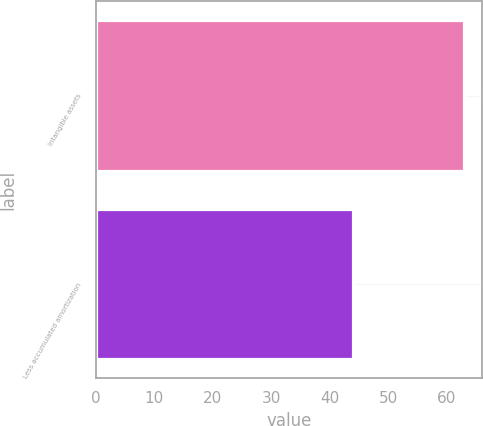<chart> <loc_0><loc_0><loc_500><loc_500><bar_chart><fcel>Intangible assets<fcel>Less accumulated amortization<nl><fcel>63<fcel>44<nl></chart> 